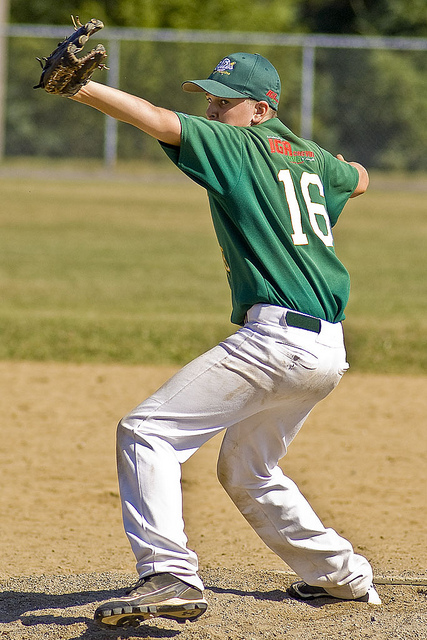<image>What brand of glove is the player using? I don't know what brand of glove the player is using. The answers suggest that it could be Spalding, Wilson, Nike, or Rawlings. What brand of glove is the player using? I don't know what brand of glove the player is using. It can be seen 'spalding', 'wilson', 'nike', 'unknown', or 'rawlings'. 